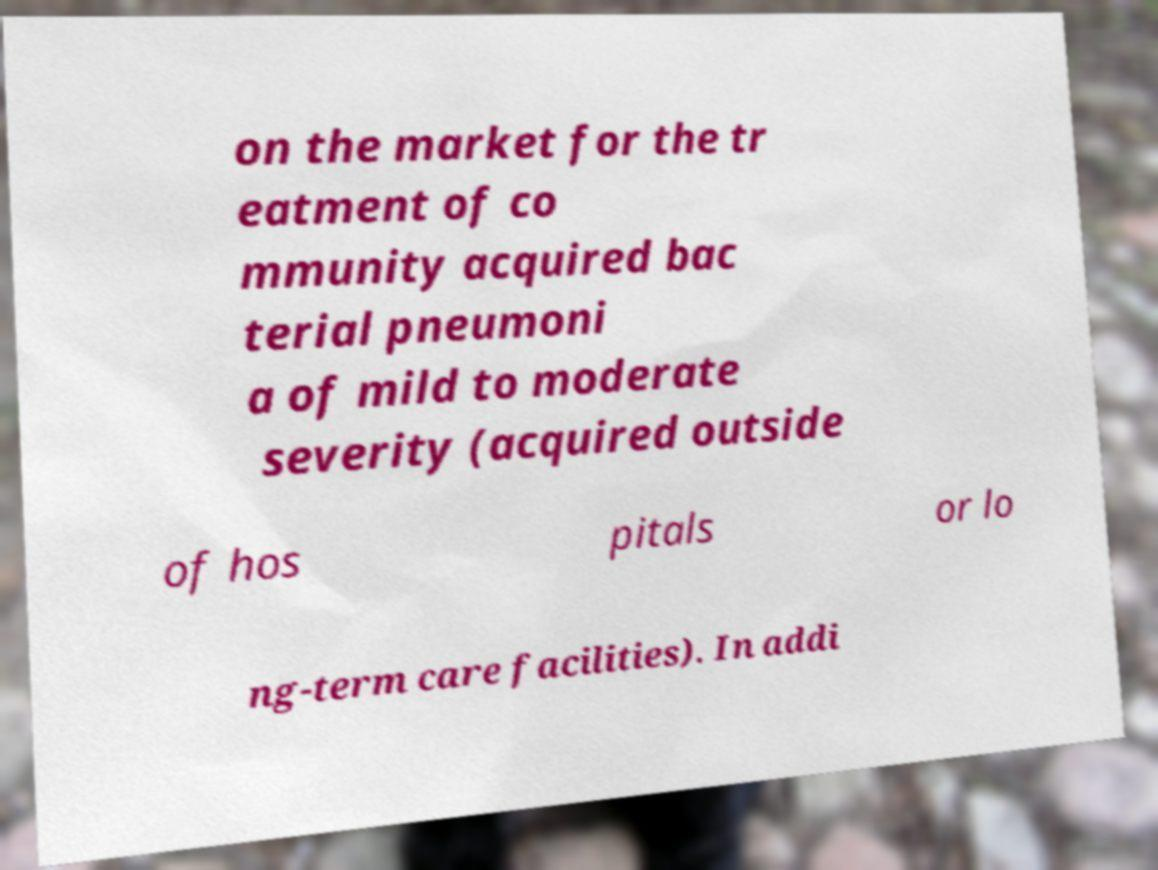Can you read and provide the text displayed in the image?This photo seems to have some interesting text. Can you extract and type it out for me? on the market for the tr eatment of co mmunity acquired bac terial pneumoni a of mild to moderate severity (acquired outside of hos pitals or lo ng-term care facilities). In addi 